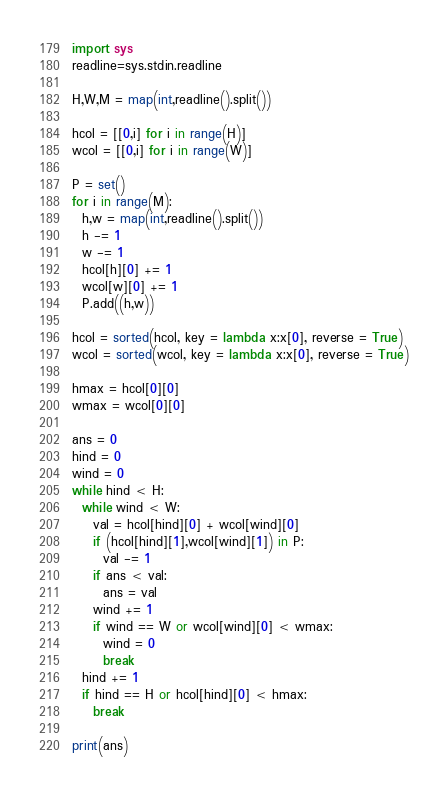Convert code to text. <code><loc_0><loc_0><loc_500><loc_500><_Python_>import sys
readline=sys.stdin.readline

H,W,M = map(int,readline().split())

hcol = [[0,i] for i in range(H)]
wcol = [[0,i] for i in range(W)]

P = set()
for i in range(M):
  h,w = map(int,readline().split())
  h -= 1
  w -= 1
  hcol[h][0] += 1
  wcol[w][0] += 1
  P.add((h,w))
  
hcol = sorted(hcol, key = lambda x:x[0], reverse = True)
wcol = sorted(wcol, key = lambda x:x[0], reverse = True)

hmax = hcol[0][0]
wmax = wcol[0][0]

ans = 0
hind = 0
wind = 0
while hind < H:
  while wind < W:
    val = hcol[hind][0] + wcol[wind][0]
    if (hcol[hind][1],wcol[wind][1]) in P:
      val -= 1
    if ans < val:
      ans = val
    wind += 1
    if wind == W or wcol[wind][0] < wmax:
      wind = 0
      break
  hind += 1
  if hind == H or hcol[hind][0] < hmax:
    break
    
print(ans)

</code> 